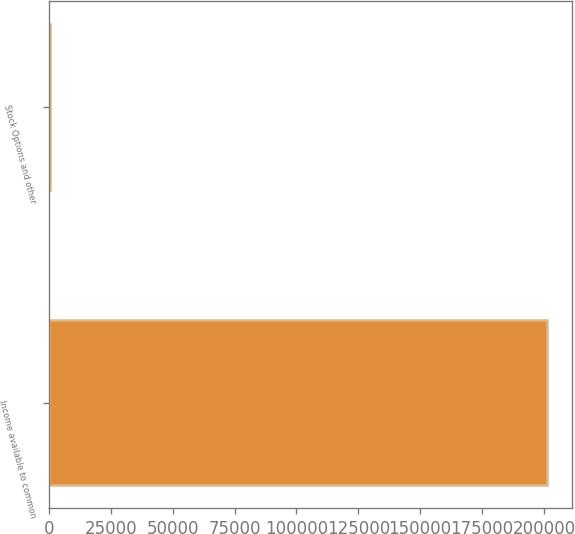Convert chart. <chart><loc_0><loc_0><loc_500><loc_500><bar_chart><fcel>Income available to common<fcel>Stock Options and other<nl><fcel>201440<fcel>244<nl></chart> 